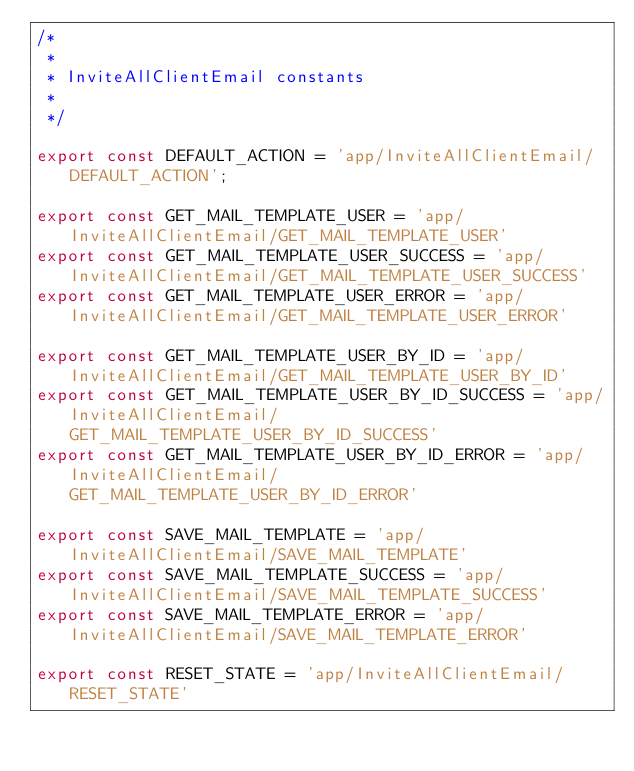<code> <loc_0><loc_0><loc_500><loc_500><_JavaScript_>/*
 *
 * InviteAllClientEmail constants
 *
 */

export const DEFAULT_ACTION = 'app/InviteAllClientEmail/DEFAULT_ACTION';

export const GET_MAIL_TEMPLATE_USER = 'app/InviteAllClientEmail/GET_MAIL_TEMPLATE_USER'
export const GET_MAIL_TEMPLATE_USER_SUCCESS = 'app/InviteAllClientEmail/GET_MAIL_TEMPLATE_USER_SUCCESS'
export const GET_MAIL_TEMPLATE_USER_ERROR = 'app/InviteAllClientEmail/GET_MAIL_TEMPLATE_USER_ERROR'

export const GET_MAIL_TEMPLATE_USER_BY_ID = 'app/InviteAllClientEmail/GET_MAIL_TEMPLATE_USER_BY_ID'
export const GET_MAIL_TEMPLATE_USER_BY_ID_SUCCESS = 'app/InviteAllClientEmail/GET_MAIL_TEMPLATE_USER_BY_ID_SUCCESS'
export const GET_MAIL_TEMPLATE_USER_BY_ID_ERROR = 'app/InviteAllClientEmail/GET_MAIL_TEMPLATE_USER_BY_ID_ERROR'

export const SAVE_MAIL_TEMPLATE = 'app/InviteAllClientEmail/SAVE_MAIL_TEMPLATE'
export const SAVE_MAIL_TEMPLATE_SUCCESS = 'app/InviteAllClientEmail/SAVE_MAIL_TEMPLATE_SUCCESS'
export const SAVE_MAIL_TEMPLATE_ERROR = 'app/InviteAllClientEmail/SAVE_MAIL_TEMPLATE_ERROR'

export const RESET_STATE = 'app/InviteAllClientEmail/RESET_STATE'</code> 